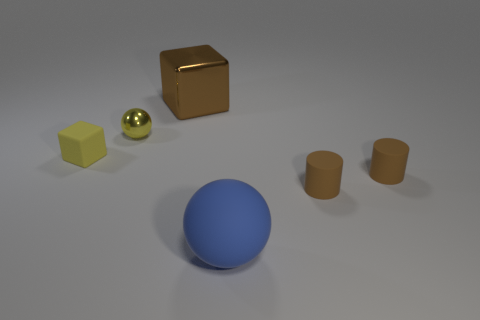Add 3 large red rubber cylinders. How many objects exist? 9 Subtract all cylinders. How many objects are left? 4 Subtract 1 blocks. How many blocks are left? 1 Subtract all gray cylinders. Subtract all green blocks. How many cylinders are left? 2 Subtract all tiny yellow metal objects. Subtract all large blue objects. How many objects are left? 4 Add 5 small objects. How many small objects are left? 9 Add 1 small yellow cylinders. How many small yellow cylinders exist? 1 Subtract all yellow spheres. How many spheres are left? 1 Subtract 0 cyan cylinders. How many objects are left? 6 